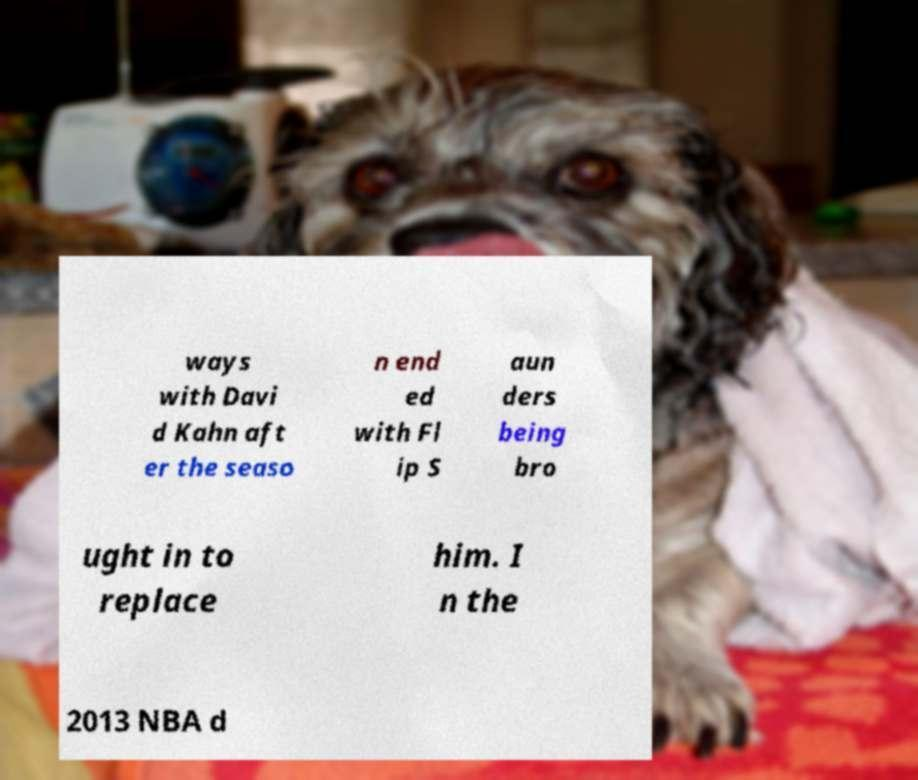For documentation purposes, I need the text within this image transcribed. Could you provide that? ways with Davi d Kahn aft er the seaso n end ed with Fl ip S aun ders being bro ught in to replace him. I n the 2013 NBA d 